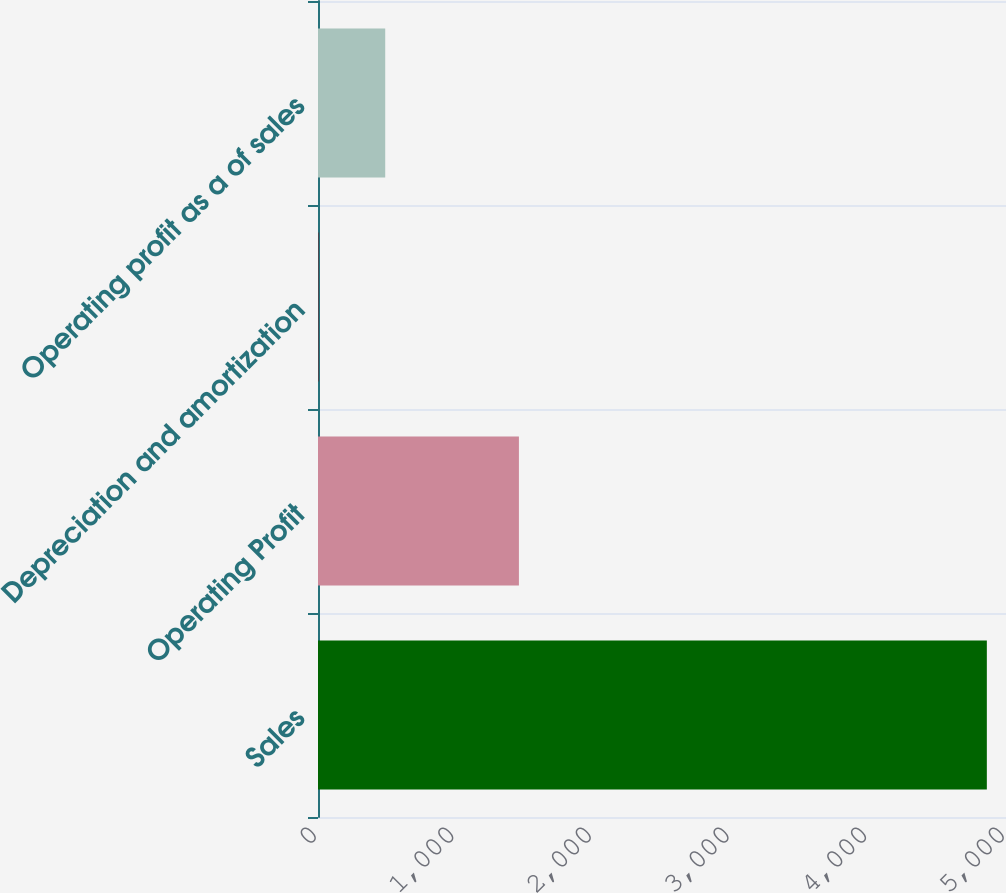Convert chart. <chart><loc_0><loc_0><loc_500><loc_500><bar_chart><fcel>Sales<fcel>Operating Profit<fcel>Depreciation and amortization<fcel>Operating profit as a of sales<nl><fcel>4860.8<fcel>1460.13<fcel>2.7<fcel>488.51<nl></chart> 